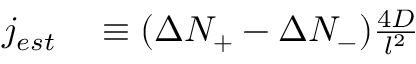Convert formula to latex. <formula><loc_0><loc_0><loc_500><loc_500>\begin{array} { r l } { j _ { e s t } } & \equiv ( \Delta N _ { + } - \Delta N _ { - } ) \frac { 4 D } { l ^ { 2 } } } \end{array}</formula> 